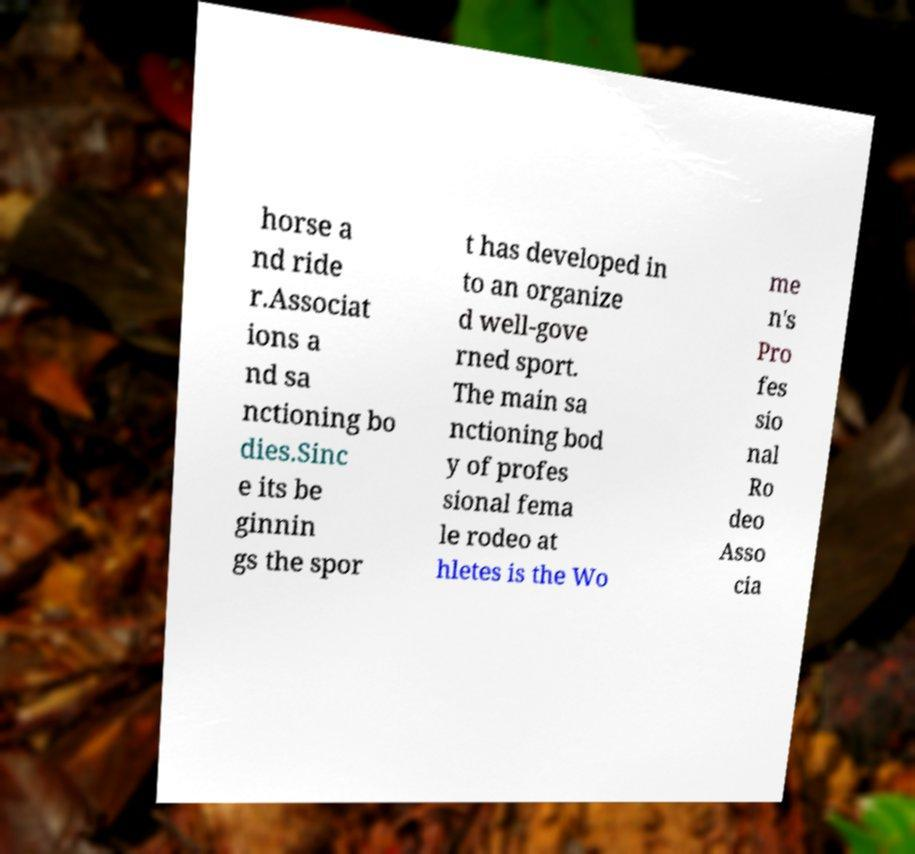What messages or text are displayed in this image? I need them in a readable, typed format. horse a nd ride r.Associat ions a nd sa nctioning bo dies.Sinc e its be ginnin gs the spor t has developed in to an organize d well-gove rned sport. The main sa nctioning bod y of profes sional fema le rodeo at hletes is the Wo me n's Pro fes sio nal Ro deo Asso cia 